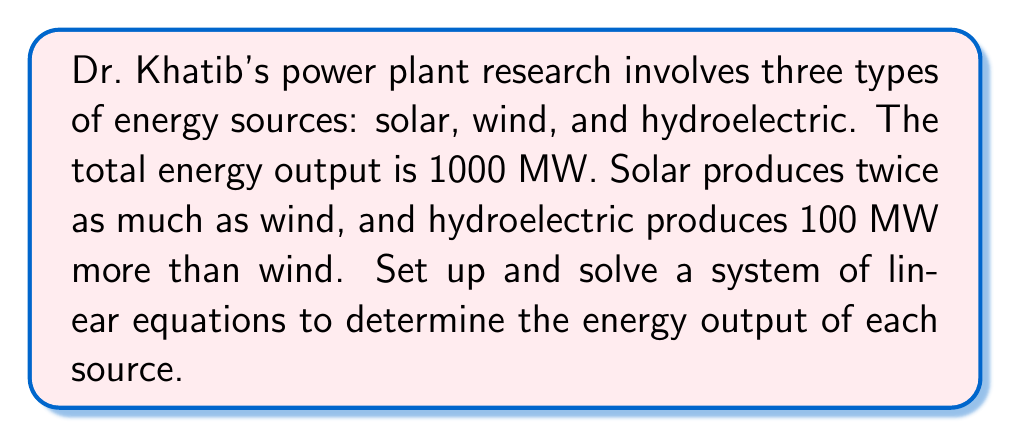Could you help me with this problem? Let's define our variables:
$x$ = wind energy output (MW)
$y$ = solar energy output (MW)
$z$ = hydroelectric energy output (MW)

Now, we can set up our system of equations based on the given information:

1. Total energy output equation:
   $x + y + z = 1000$

2. Solar produces twice as much as wind:
   $y = 2x$

3. Hydroelectric produces 100 MW more than wind:
   $z = x + 100$

Let's solve this system using substitution:

Step 1: Substitute $y$ and $z$ in the first equation
$x + 2x + (x + 100) = 1000$

Step 2: Simplify
$4x + 100 = 1000$

Step 3: Solve for $x$
$4x = 900$
$x = 225$

Step 4: Calculate $y$ and $z$
$y = 2x = 2(225) = 450$
$z = x + 100 = 225 + 100 = 325$

Therefore, the energy output for each source is:
Wind: 225 MW
Solar: 450 MW
Hydroelectric: 325 MW
Answer: Wind: 225 MW, Solar: 450 MW, Hydroelectric: 325 MW 